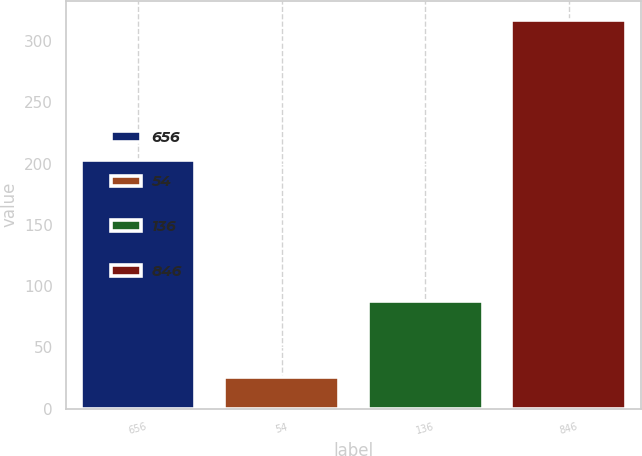Convert chart. <chart><loc_0><loc_0><loc_500><loc_500><bar_chart><fcel>656<fcel>54<fcel>136<fcel>846<nl><fcel>203<fcel>26<fcel>88<fcel>317<nl></chart> 